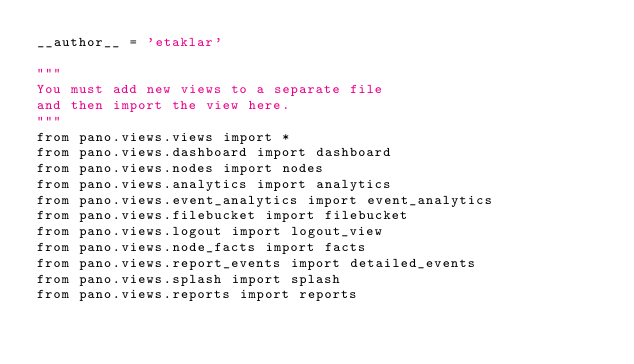<code> <loc_0><loc_0><loc_500><loc_500><_Python_>__author__ = 'etaklar'

"""
You must add new views to a separate file
and then import the view here.
"""
from pano.views.views import *
from pano.views.dashboard import dashboard
from pano.views.nodes import nodes
from pano.views.analytics import analytics
from pano.views.event_analytics import event_analytics
from pano.views.filebucket import filebucket
from pano.views.logout import logout_view
from pano.views.node_facts import facts
from pano.views.report_events import detailed_events
from pano.views.splash import splash
from pano.views.reports import reports
</code> 